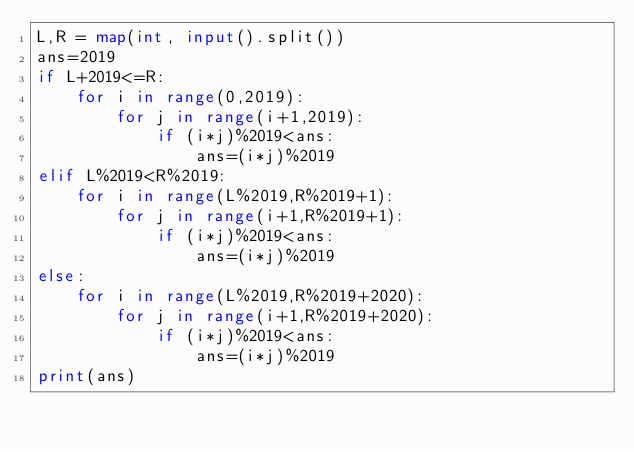<code> <loc_0><loc_0><loc_500><loc_500><_Python_>L,R = map(int, input().split())
ans=2019
if L+2019<=R:
    for i in range(0,2019):
        for j in range(i+1,2019):
            if (i*j)%2019<ans:
                ans=(i*j)%2019
elif L%2019<R%2019:
    for i in range(L%2019,R%2019+1):
        for j in range(i+1,R%2019+1):
            if (i*j)%2019<ans:
                ans=(i*j)%2019
else:
    for i in range(L%2019,R%2019+2020):
        for j in range(i+1,R%2019+2020):
            if (i*j)%2019<ans:
                ans=(i*j)%2019
print(ans)</code> 